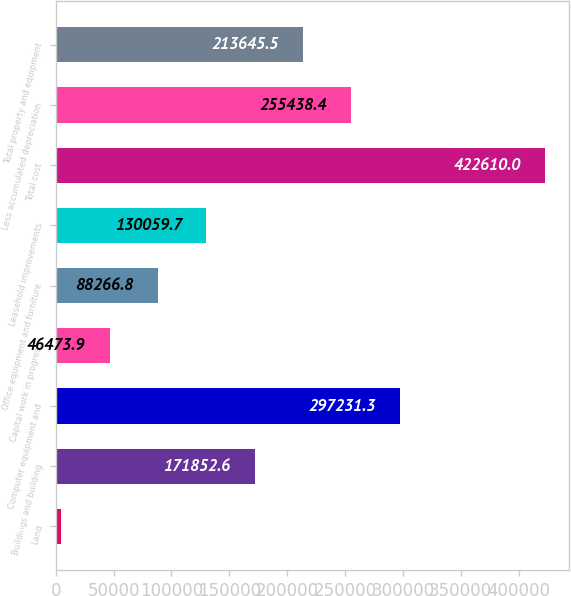Convert chart. <chart><loc_0><loc_0><loc_500><loc_500><bar_chart><fcel>Land<fcel>Buildings and building<fcel>Computer equipment and<fcel>Capital work in progress<fcel>Office equipment and furniture<fcel>Leasehold improvements<fcel>Total cost<fcel>Less accumulated depreciation<fcel>Total property and equipment<nl><fcel>4681<fcel>171853<fcel>297231<fcel>46473.9<fcel>88266.8<fcel>130060<fcel>422610<fcel>255438<fcel>213646<nl></chart> 